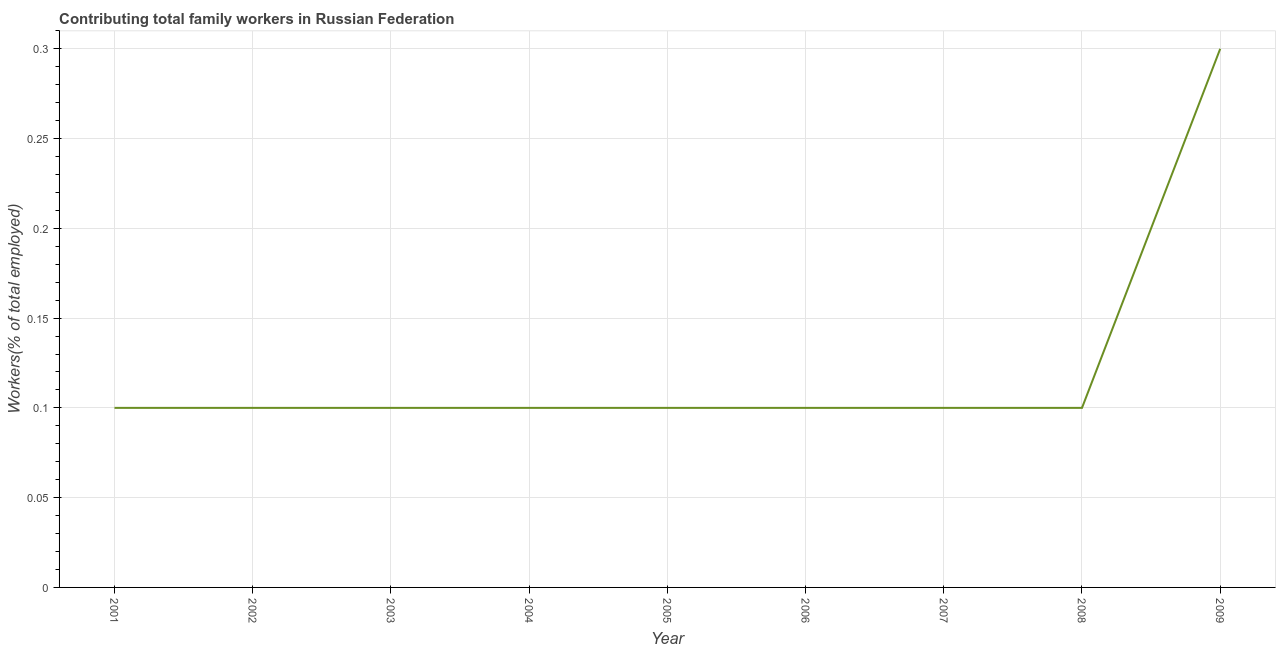What is the contributing family workers in 2008?
Make the answer very short. 0.1. Across all years, what is the maximum contributing family workers?
Provide a short and direct response. 0.3. Across all years, what is the minimum contributing family workers?
Give a very brief answer. 0.1. In which year was the contributing family workers minimum?
Offer a very short reply. 2001. What is the sum of the contributing family workers?
Provide a succinct answer. 1.1. What is the difference between the contributing family workers in 2003 and 2009?
Provide a short and direct response. -0.2. What is the average contributing family workers per year?
Your response must be concise. 0.12. What is the median contributing family workers?
Your answer should be very brief. 0.1. Do a majority of the years between 2009 and 2008 (inclusive) have contributing family workers greater than 0.060000000000000005 %?
Make the answer very short. No. What is the ratio of the contributing family workers in 2004 to that in 2009?
Your answer should be very brief. 0.33. Is the contributing family workers in 2005 less than that in 2009?
Provide a succinct answer. Yes. What is the difference between the highest and the second highest contributing family workers?
Offer a very short reply. 0.2. What is the difference between the highest and the lowest contributing family workers?
Provide a short and direct response. 0.2. In how many years, is the contributing family workers greater than the average contributing family workers taken over all years?
Your answer should be very brief. 1. Does the contributing family workers monotonically increase over the years?
Your answer should be compact. No. How many lines are there?
Keep it short and to the point. 1. How many years are there in the graph?
Offer a terse response. 9. Are the values on the major ticks of Y-axis written in scientific E-notation?
Offer a terse response. No. Does the graph contain any zero values?
Offer a terse response. No. What is the title of the graph?
Your response must be concise. Contributing total family workers in Russian Federation. What is the label or title of the Y-axis?
Your answer should be very brief. Workers(% of total employed). What is the Workers(% of total employed) of 2001?
Your answer should be very brief. 0.1. What is the Workers(% of total employed) of 2002?
Your answer should be compact. 0.1. What is the Workers(% of total employed) in 2003?
Provide a short and direct response. 0.1. What is the Workers(% of total employed) in 2004?
Make the answer very short. 0.1. What is the Workers(% of total employed) of 2005?
Provide a succinct answer. 0.1. What is the Workers(% of total employed) of 2006?
Offer a terse response. 0.1. What is the Workers(% of total employed) in 2007?
Your answer should be compact. 0.1. What is the Workers(% of total employed) of 2008?
Make the answer very short. 0.1. What is the Workers(% of total employed) in 2009?
Make the answer very short. 0.3. What is the difference between the Workers(% of total employed) in 2001 and 2002?
Provide a succinct answer. 0. What is the difference between the Workers(% of total employed) in 2001 and 2003?
Ensure brevity in your answer.  0. What is the difference between the Workers(% of total employed) in 2001 and 2005?
Give a very brief answer. 0. What is the difference between the Workers(% of total employed) in 2001 and 2006?
Your answer should be very brief. 0. What is the difference between the Workers(% of total employed) in 2001 and 2008?
Make the answer very short. 0. What is the difference between the Workers(% of total employed) in 2002 and 2003?
Provide a short and direct response. 0. What is the difference between the Workers(% of total employed) in 2002 and 2006?
Offer a terse response. 0. What is the difference between the Workers(% of total employed) in 2002 and 2007?
Ensure brevity in your answer.  0. What is the difference between the Workers(% of total employed) in 2002 and 2009?
Provide a short and direct response. -0.2. What is the difference between the Workers(% of total employed) in 2003 and 2004?
Provide a succinct answer. 0. What is the difference between the Workers(% of total employed) in 2003 and 2006?
Your answer should be compact. 0. What is the difference between the Workers(% of total employed) in 2003 and 2009?
Make the answer very short. -0.2. What is the difference between the Workers(% of total employed) in 2004 and 2006?
Ensure brevity in your answer.  0. What is the difference between the Workers(% of total employed) in 2004 and 2008?
Make the answer very short. 0. What is the difference between the Workers(% of total employed) in 2004 and 2009?
Provide a succinct answer. -0.2. What is the difference between the Workers(% of total employed) in 2005 and 2007?
Keep it short and to the point. 0. What is the difference between the Workers(% of total employed) in 2005 and 2008?
Provide a succinct answer. 0. What is the difference between the Workers(% of total employed) in 2006 and 2007?
Your answer should be very brief. 0. What is the difference between the Workers(% of total employed) in 2006 and 2008?
Ensure brevity in your answer.  0. What is the difference between the Workers(% of total employed) in 2006 and 2009?
Offer a very short reply. -0.2. What is the ratio of the Workers(% of total employed) in 2001 to that in 2002?
Keep it short and to the point. 1. What is the ratio of the Workers(% of total employed) in 2001 to that in 2004?
Provide a succinct answer. 1. What is the ratio of the Workers(% of total employed) in 2001 to that in 2005?
Keep it short and to the point. 1. What is the ratio of the Workers(% of total employed) in 2001 to that in 2007?
Your answer should be very brief. 1. What is the ratio of the Workers(% of total employed) in 2001 to that in 2008?
Give a very brief answer. 1. What is the ratio of the Workers(% of total employed) in 2001 to that in 2009?
Keep it short and to the point. 0.33. What is the ratio of the Workers(% of total employed) in 2002 to that in 2004?
Make the answer very short. 1. What is the ratio of the Workers(% of total employed) in 2002 to that in 2005?
Provide a short and direct response. 1. What is the ratio of the Workers(% of total employed) in 2002 to that in 2006?
Give a very brief answer. 1. What is the ratio of the Workers(% of total employed) in 2002 to that in 2008?
Provide a succinct answer. 1. What is the ratio of the Workers(% of total employed) in 2002 to that in 2009?
Your answer should be compact. 0.33. What is the ratio of the Workers(% of total employed) in 2003 to that in 2004?
Your answer should be compact. 1. What is the ratio of the Workers(% of total employed) in 2003 to that in 2006?
Your answer should be compact. 1. What is the ratio of the Workers(% of total employed) in 2003 to that in 2007?
Make the answer very short. 1. What is the ratio of the Workers(% of total employed) in 2003 to that in 2008?
Offer a terse response. 1. What is the ratio of the Workers(% of total employed) in 2003 to that in 2009?
Your response must be concise. 0.33. What is the ratio of the Workers(% of total employed) in 2004 to that in 2009?
Provide a short and direct response. 0.33. What is the ratio of the Workers(% of total employed) in 2005 to that in 2006?
Your response must be concise. 1. What is the ratio of the Workers(% of total employed) in 2005 to that in 2007?
Keep it short and to the point. 1. What is the ratio of the Workers(% of total employed) in 2005 to that in 2009?
Give a very brief answer. 0.33. What is the ratio of the Workers(% of total employed) in 2006 to that in 2009?
Your answer should be very brief. 0.33. What is the ratio of the Workers(% of total employed) in 2007 to that in 2008?
Your response must be concise. 1. What is the ratio of the Workers(% of total employed) in 2007 to that in 2009?
Give a very brief answer. 0.33. What is the ratio of the Workers(% of total employed) in 2008 to that in 2009?
Your answer should be compact. 0.33. 